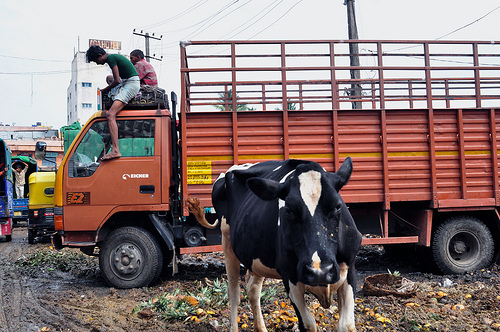<image>
Can you confirm if the cow is in the car? No. The cow is not contained within the car. These objects have a different spatial relationship. Is there a worker on the vehicle? Yes. Looking at the image, I can see the worker is positioned on top of the vehicle, with the vehicle providing support. 